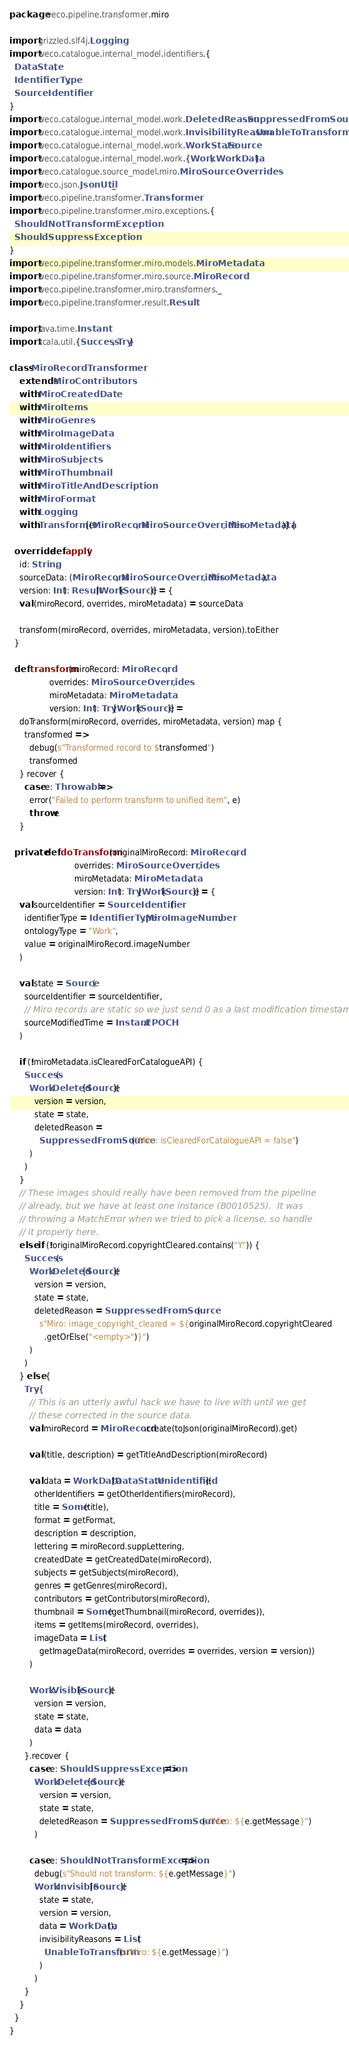<code> <loc_0><loc_0><loc_500><loc_500><_Scala_>package weco.pipeline.transformer.miro

import grizzled.slf4j.Logging
import weco.catalogue.internal_model.identifiers.{
  DataState,
  IdentifierType,
  SourceIdentifier
}
import weco.catalogue.internal_model.work.DeletedReason.SuppressedFromSource
import weco.catalogue.internal_model.work.InvisibilityReason.UnableToTransform
import weco.catalogue.internal_model.work.WorkState.Source
import weco.catalogue.internal_model.work.{Work, WorkData}
import weco.catalogue.source_model.miro.MiroSourceOverrides
import weco.json.JsonUtil._
import weco.pipeline.transformer.Transformer
import weco.pipeline.transformer.miro.exceptions.{
  ShouldNotTransformException,
  ShouldSuppressException
}
import weco.pipeline.transformer.miro.models.MiroMetadata
import weco.pipeline.transformer.miro.source.MiroRecord
import weco.pipeline.transformer.miro.transformers._
import weco.pipeline.transformer.result.Result

import java.time.Instant
import scala.util.{Success, Try}

class MiroRecordTransformer
    extends MiroContributors
    with MiroCreatedDate
    with MiroItems
    with MiroGenres
    with MiroImageData
    with MiroIdentifiers
    with MiroSubjects
    with MiroThumbnail
    with MiroTitleAndDescription
    with MiroFormat
    with Logging
    with Transformer[(MiroRecord, MiroSourceOverrides, MiroMetadata)] {

  override def apply(
    id: String,
    sourceData: (MiroRecord, MiroSourceOverrides, MiroMetadata),
    version: Int): Result[Work[Source]] = {
    val (miroRecord, overrides, miroMetadata) = sourceData

    transform(miroRecord, overrides, miroMetadata, version).toEither
  }

  def transform(miroRecord: MiroRecord,
                overrides: MiroSourceOverrides,
                miroMetadata: MiroMetadata,
                version: Int): Try[Work[Source]] =
    doTransform(miroRecord, overrides, miroMetadata, version) map {
      transformed =>
        debug(s"Transformed record to $transformed")
        transformed
    } recover {
      case e: Throwable =>
        error("Failed to perform transform to unified item", e)
        throw e
    }

  private def doTransform(originalMiroRecord: MiroRecord,
                          overrides: MiroSourceOverrides,
                          miroMetadata: MiroMetadata,
                          version: Int): Try[Work[Source]] = {
    val sourceIdentifier = SourceIdentifier(
      identifierType = IdentifierType.MiroImageNumber,
      ontologyType = "Work",
      value = originalMiroRecord.imageNumber
    )

    val state = Source(
      sourceIdentifier = sourceIdentifier,
      // Miro records are static so we just send 0 as a last modification timestamp
      sourceModifiedTime = Instant.EPOCH
    )

    if (!miroMetadata.isClearedForCatalogueAPI) {
      Success(
        Work.Deleted[Source](
          version = version,
          state = state,
          deletedReason =
            SuppressedFromSource("Miro: isClearedForCatalogueAPI = false")
        )
      )
    }
    // These images should really have been removed from the pipeline
    // already, but we have at least one instance (B0010525).  It was
    // throwing a MatchError when we tried to pick a license, so handle
    // it properly here.
    else if (!originalMiroRecord.copyrightCleared.contains("Y")) {
      Success(
        Work.Deleted[Source](
          version = version,
          state = state,
          deletedReason = SuppressedFromSource(
            s"Miro: image_copyright_cleared = ${originalMiroRecord.copyrightCleared
              .getOrElse("<empty>")}")
        )
      )
    } else {
      Try {
        // This is an utterly awful hack we have to live with until we get
        // these corrected in the source data.
        val miroRecord = MiroRecord.create(toJson(originalMiroRecord).get)

        val (title, description) = getTitleAndDescription(miroRecord)

        val data = WorkData[DataState.Unidentified](
          otherIdentifiers = getOtherIdentifiers(miroRecord),
          title = Some(title),
          format = getFormat,
          description = description,
          lettering = miroRecord.suppLettering,
          createdDate = getCreatedDate(miroRecord),
          subjects = getSubjects(miroRecord),
          genres = getGenres(miroRecord),
          contributors = getContributors(miroRecord),
          thumbnail = Some(getThumbnail(miroRecord, overrides)),
          items = getItems(miroRecord, overrides),
          imageData = List(
            getImageData(miroRecord, overrides = overrides, version = version))
        )

        Work.Visible[Source](
          version = version,
          state = state,
          data = data
        )
      }.recover {
        case e: ShouldSuppressException =>
          Work.Deleted[Source](
            version = version,
            state = state,
            deletedReason = SuppressedFromSource(s"Miro: ${e.getMessage}")
          )

        case e: ShouldNotTransformException =>
          debug(s"Should not transform: ${e.getMessage}")
          Work.Invisible[Source](
            state = state,
            version = version,
            data = WorkData(),
            invisibilityReasons = List(
              UnableToTransform(s"Miro: ${e.getMessage}")
            )
          )
      }
    }
  }
}
</code> 